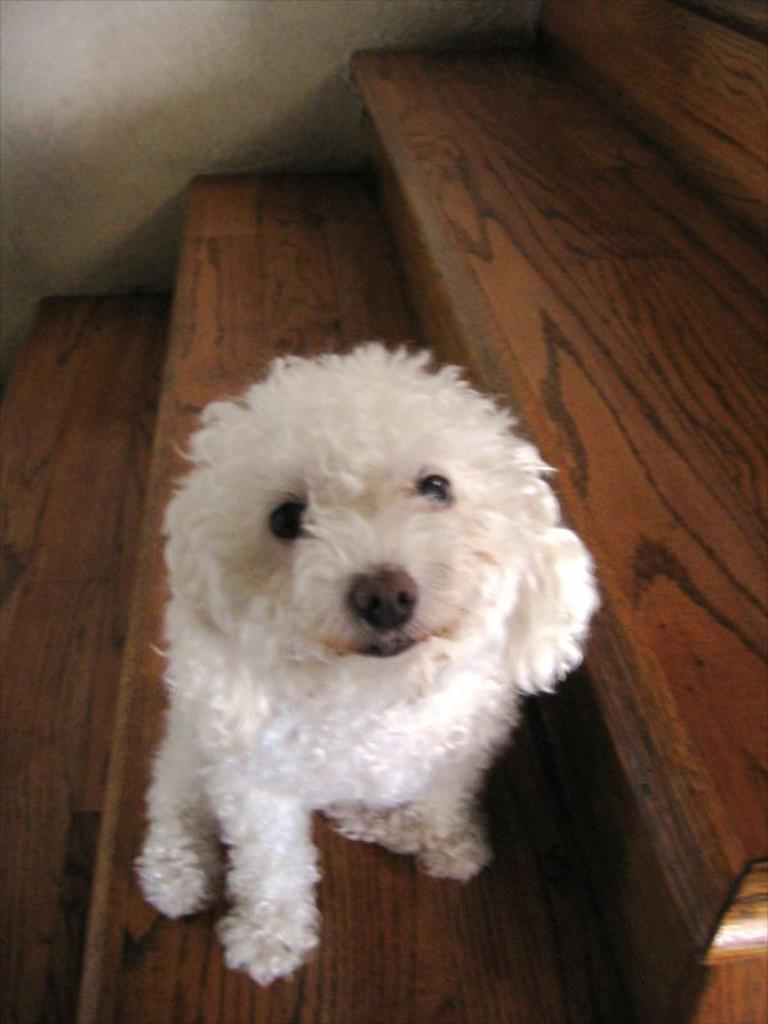What type of animal is in the image? There is a white color dog in the image. Where is the dog located in the image? The dog is on wooden stairs. What is the dog thinking about in the image? The image does not provide information about the dog's thoughts, so we cannot determine what the dog is thinking. 